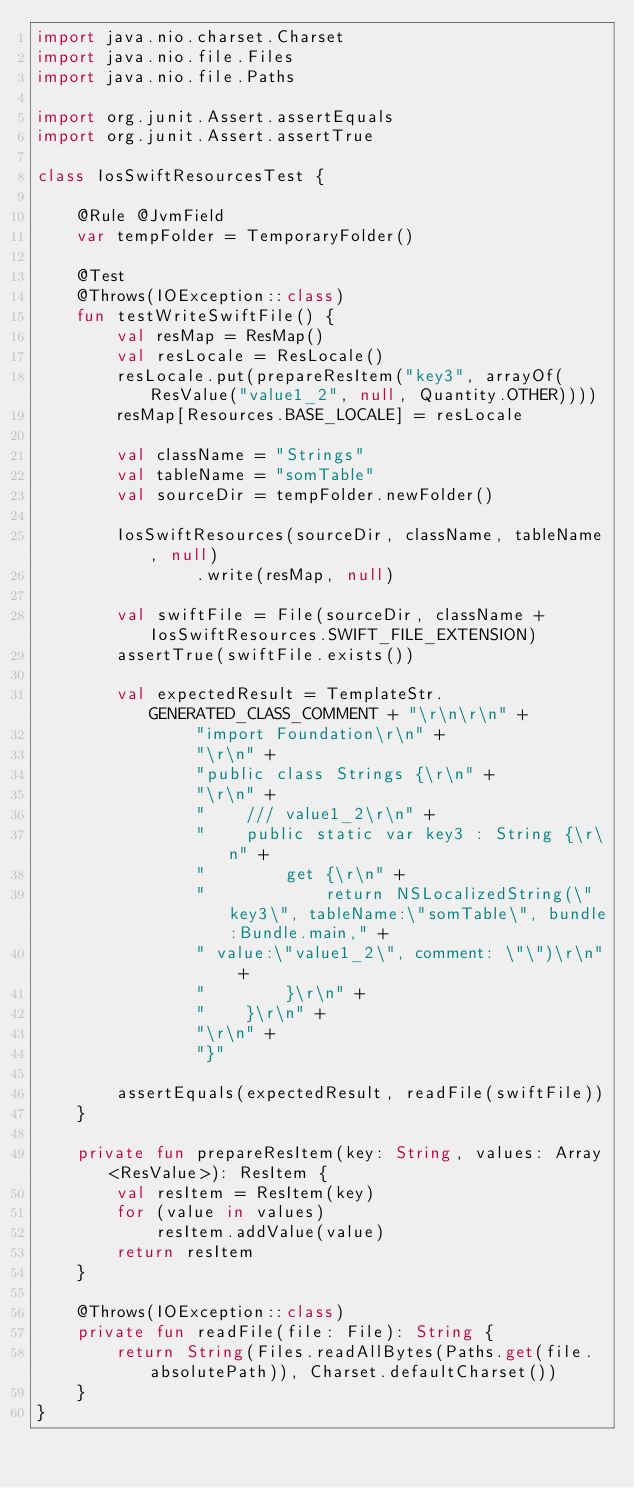<code> <loc_0><loc_0><loc_500><loc_500><_Kotlin_>import java.nio.charset.Charset
import java.nio.file.Files
import java.nio.file.Paths

import org.junit.Assert.assertEquals
import org.junit.Assert.assertTrue

class IosSwiftResourcesTest {

    @Rule @JvmField
    var tempFolder = TemporaryFolder()

    @Test
    @Throws(IOException::class)
    fun testWriteSwiftFile() {
        val resMap = ResMap()
        val resLocale = ResLocale()
        resLocale.put(prepareResItem("key3", arrayOf(ResValue("value1_2", null, Quantity.OTHER))))
        resMap[Resources.BASE_LOCALE] = resLocale

        val className = "Strings"
        val tableName = "somTable"
        val sourceDir = tempFolder.newFolder()

        IosSwiftResources(sourceDir, className, tableName, null)
                .write(resMap, null)

        val swiftFile = File(sourceDir, className + IosSwiftResources.SWIFT_FILE_EXTENSION)
        assertTrue(swiftFile.exists())

        val expectedResult = TemplateStr.GENERATED_CLASS_COMMENT + "\r\n\r\n" +
                "import Foundation\r\n" +
                "\r\n" +
                "public class Strings {\r\n" +
                "\r\n" +
                "    /// value1_2\r\n" +
                "    public static var key3 : String {\r\n" +
                "        get {\r\n" +
                "            return NSLocalizedString(\"key3\", tableName:\"somTable\", bundle:Bundle.main," +
                " value:\"value1_2\", comment: \"\")\r\n" +
                "        }\r\n" +
                "    }\r\n" +
                "\r\n" +
                "}"

        assertEquals(expectedResult, readFile(swiftFile))
    }

    private fun prepareResItem(key: String, values: Array<ResValue>): ResItem {
        val resItem = ResItem(key)
        for (value in values)
            resItem.addValue(value)
        return resItem
    }

    @Throws(IOException::class)
    private fun readFile(file: File): String {
        return String(Files.readAllBytes(Paths.get(file.absolutePath)), Charset.defaultCharset())
    }
}
</code> 